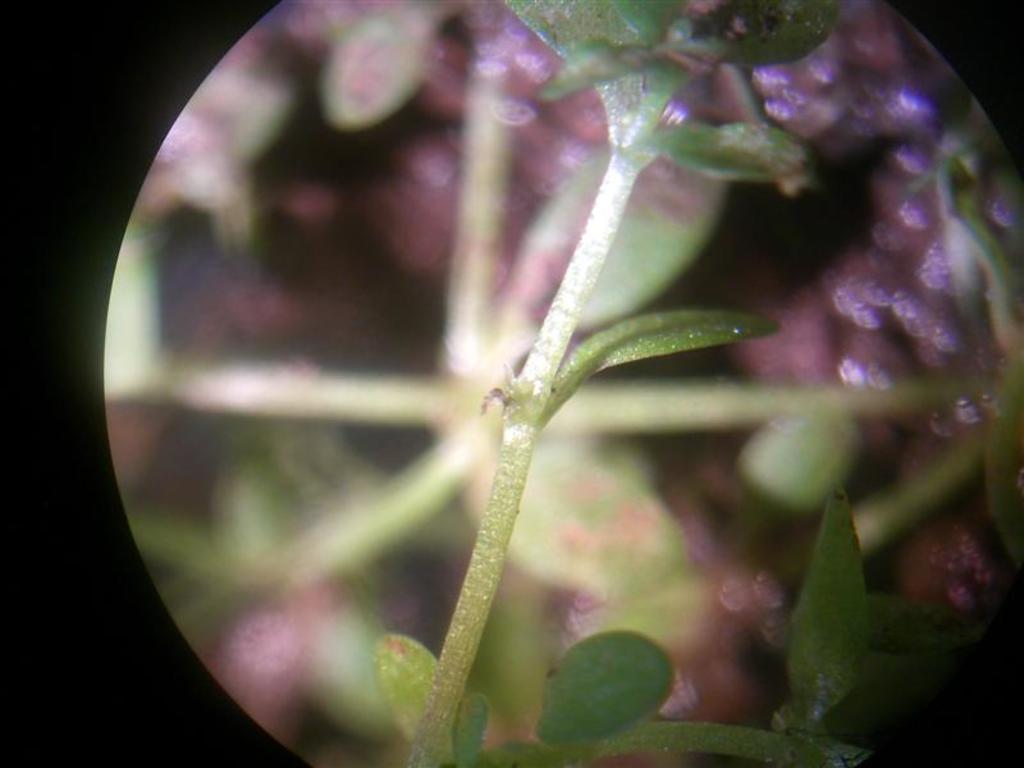Describe this image in one or two sentences. In this image, we can see a plant on the blur background. 